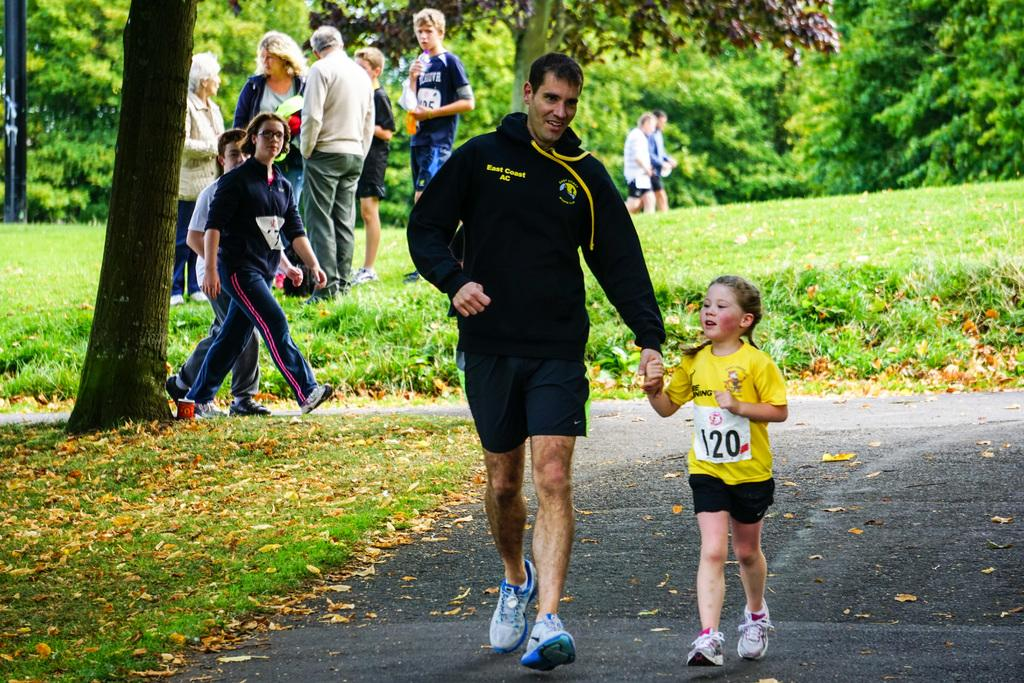How many people are walking on the road in the image? There are four people walking on the road in the image. What can be seen on the grass in the image? Dried leaves are present on the grass in the image. What is visible in the background of the image? There are people and trees visible in the background of the image. What shape is the development taking in the image? There is no reference to any development in the image; it features four people walking on the road and dried leaves on the grass. Can you hear the people talking in the image? The image is a still picture, so there is no sound or indication of people talking. 